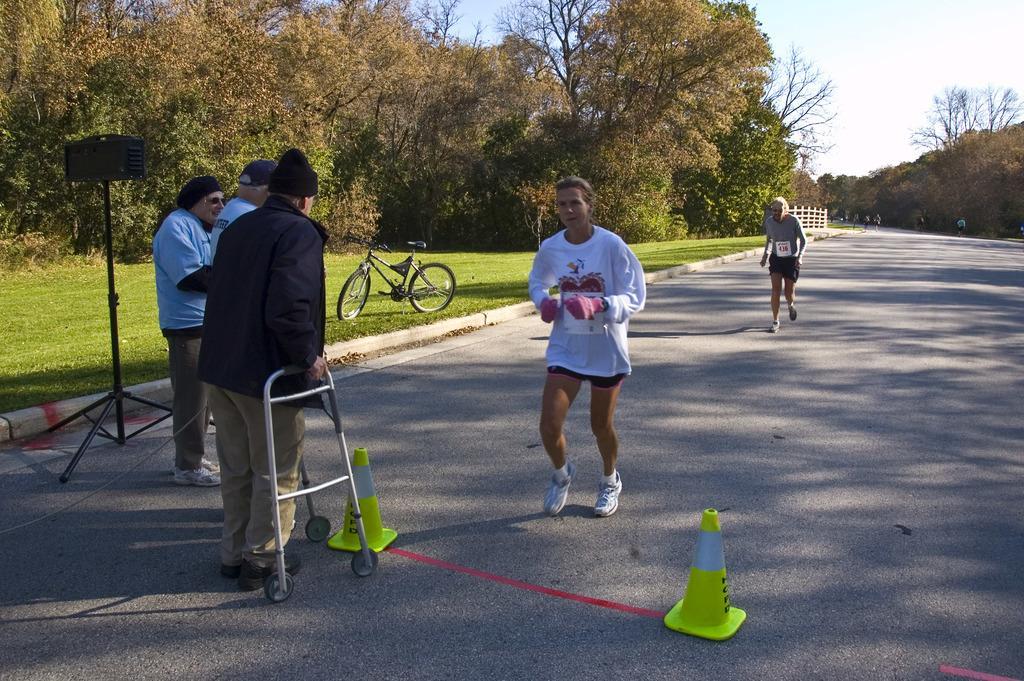Could you give a brief overview of what you see in this image? This picture describes about group of people, few are running and few are standing, in front of them we can find few road divider cones and a stand, in the background we can see a bicycle on the grass, and also we can see trees. 